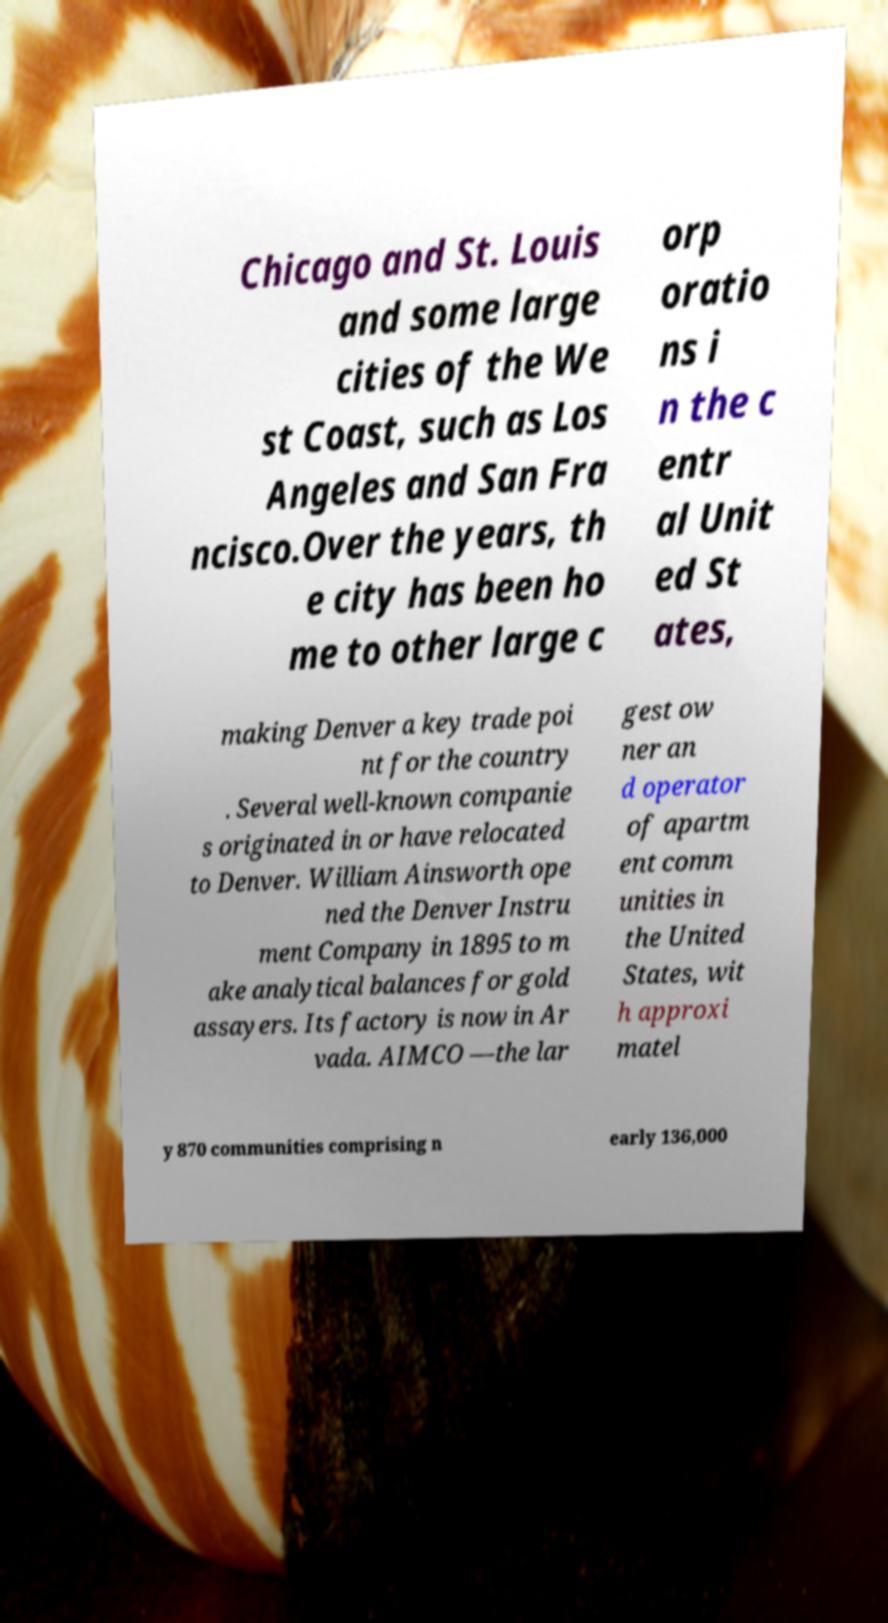Can you accurately transcribe the text from the provided image for me? Chicago and St. Louis and some large cities of the We st Coast, such as Los Angeles and San Fra ncisco.Over the years, th e city has been ho me to other large c orp oratio ns i n the c entr al Unit ed St ates, making Denver a key trade poi nt for the country . Several well-known companie s originated in or have relocated to Denver. William Ainsworth ope ned the Denver Instru ment Company in 1895 to m ake analytical balances for gold assayers. Its factory is now in Ar vada. AIMCO —the lar gest ow ner an d operator of apartm ent comm unities in the United States, wit h approxi matel y 870 communities comprising n early 136,000 